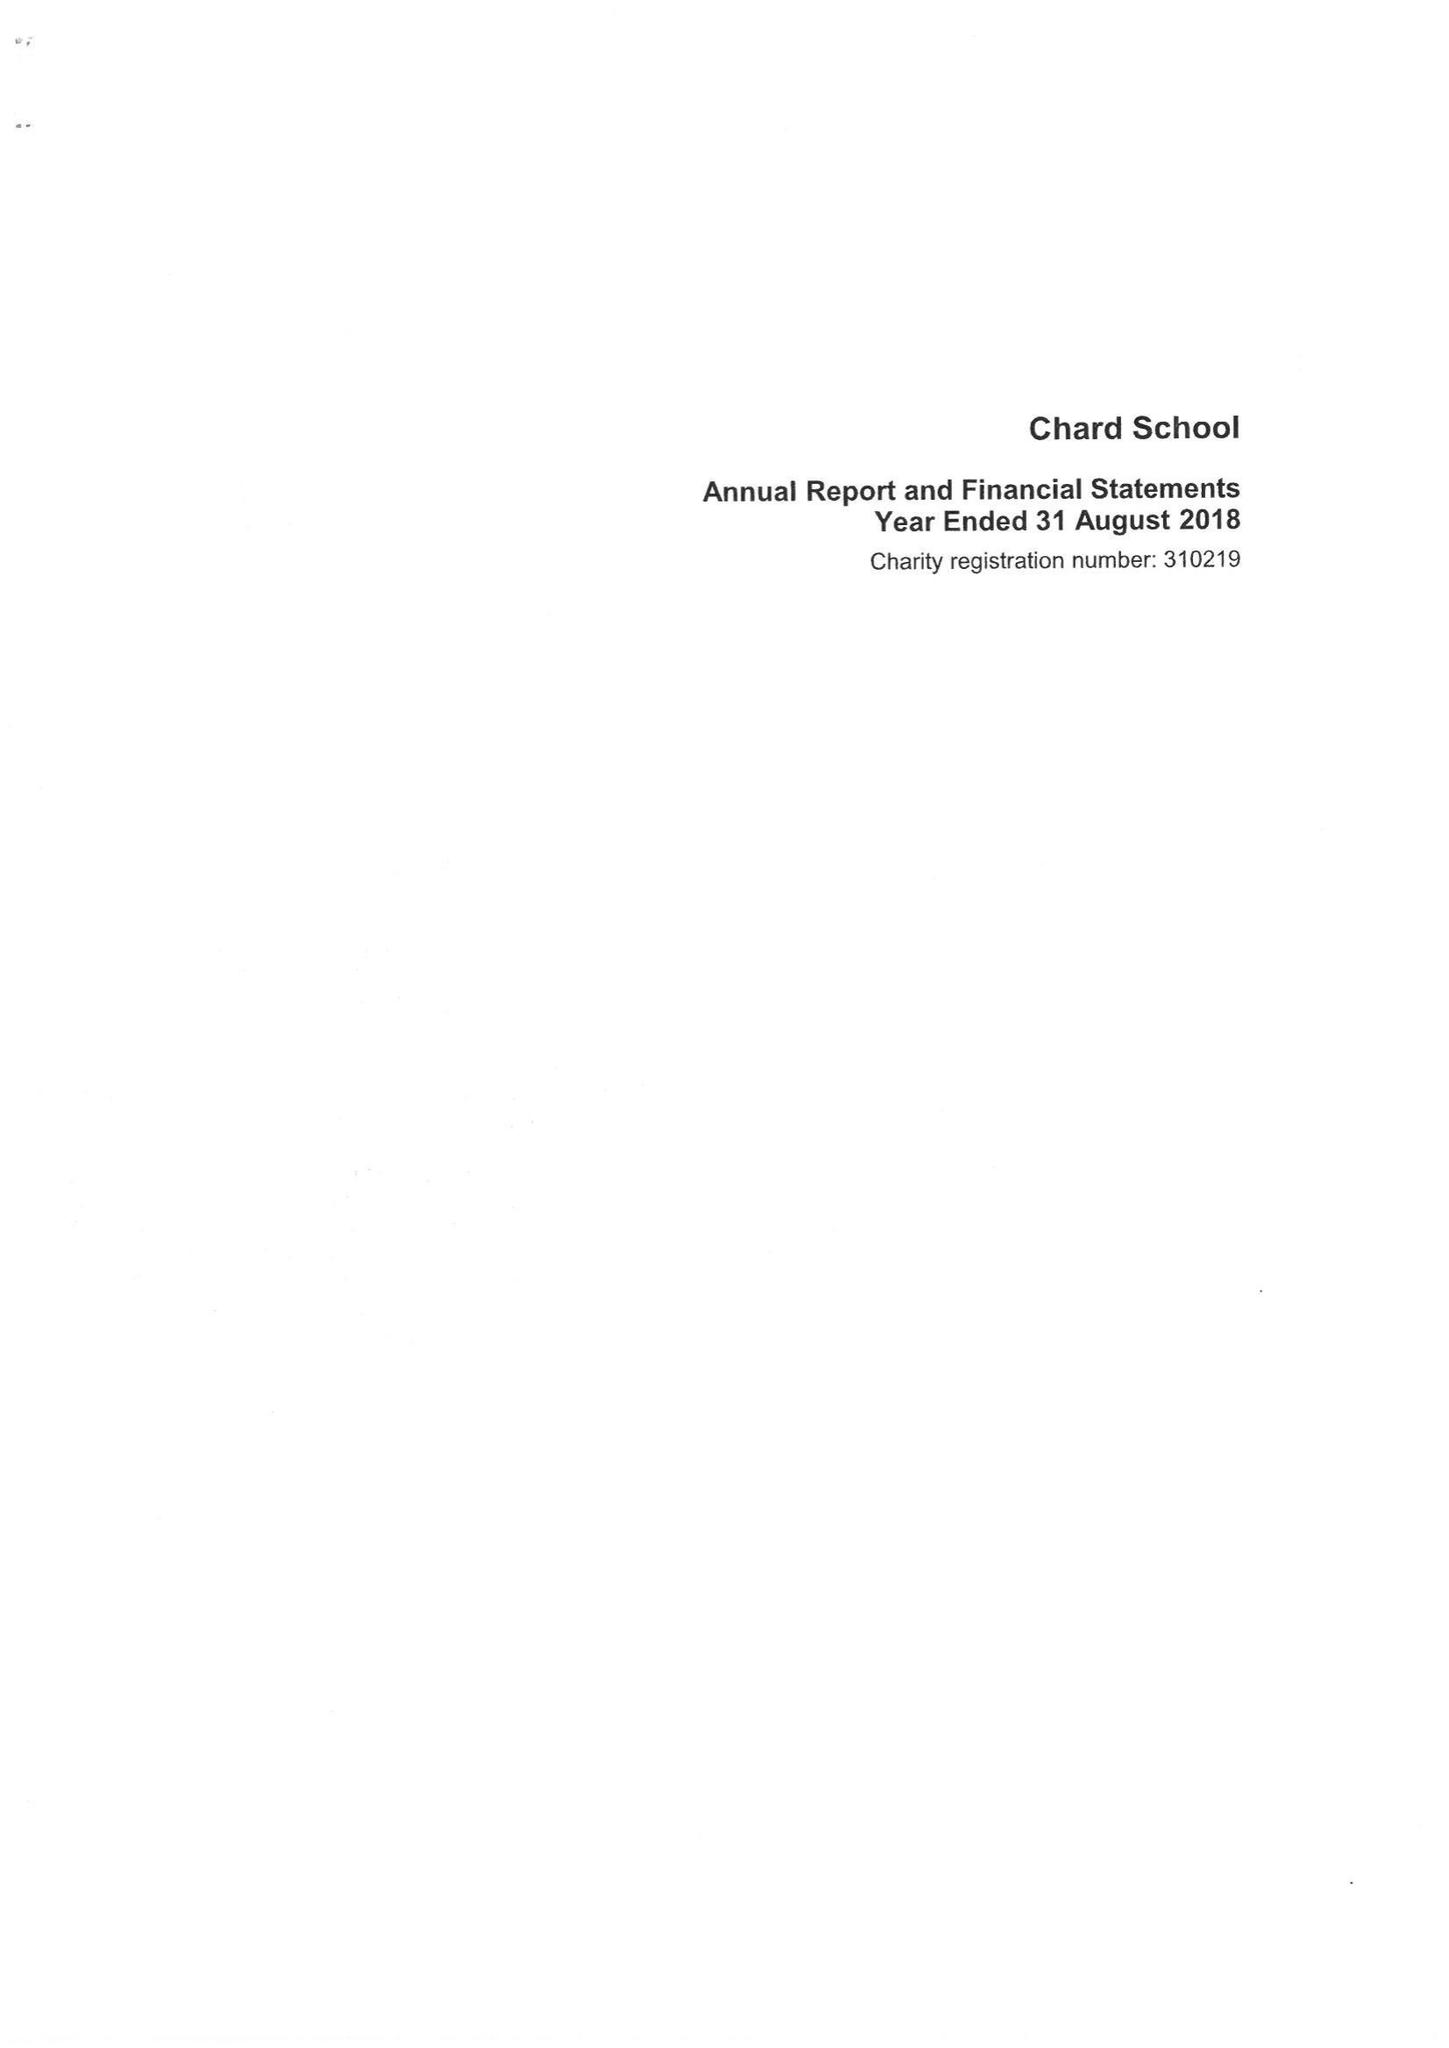What is the value for the income_annually_in_british_pounds?
Answer the question using a single word or phrase. 490786.00 